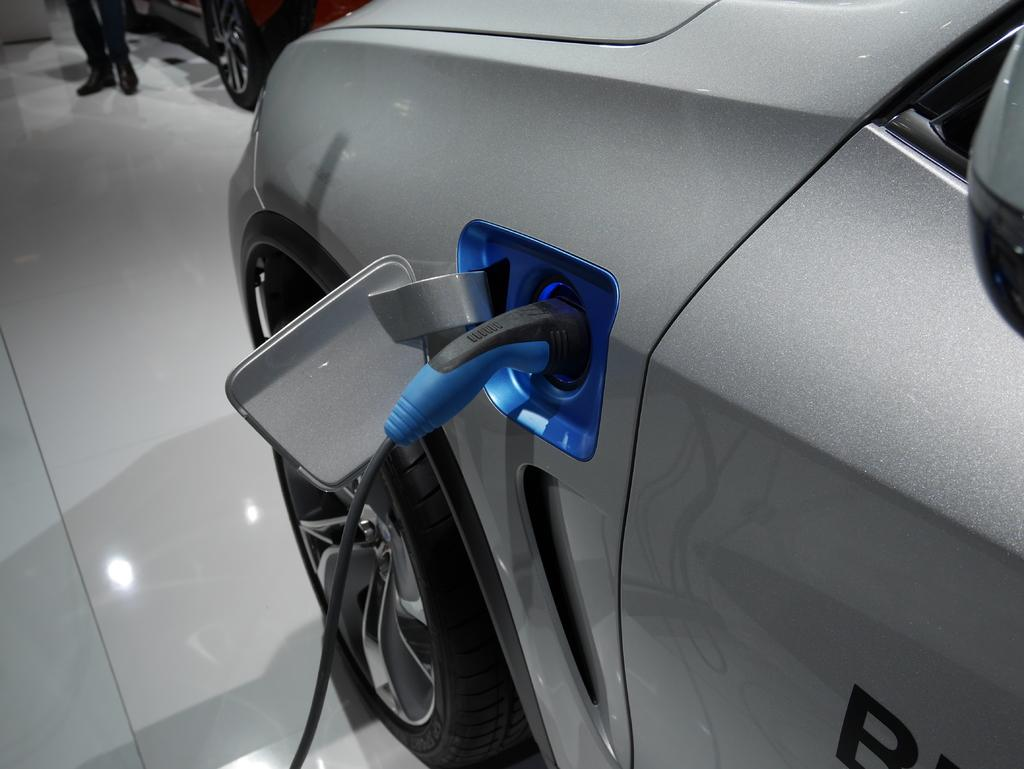What is the main subject of the image? There are two main subjects in the image, which are cars. How many cars can be seen in the image? There are two cars visible in the image. Can you describe any other elements in the image? Person legs are visible in the top left of the image. What type of whistle can be heard coming from the car in the image? There is no whistle present in the image, and therefore no sound can be heard. 